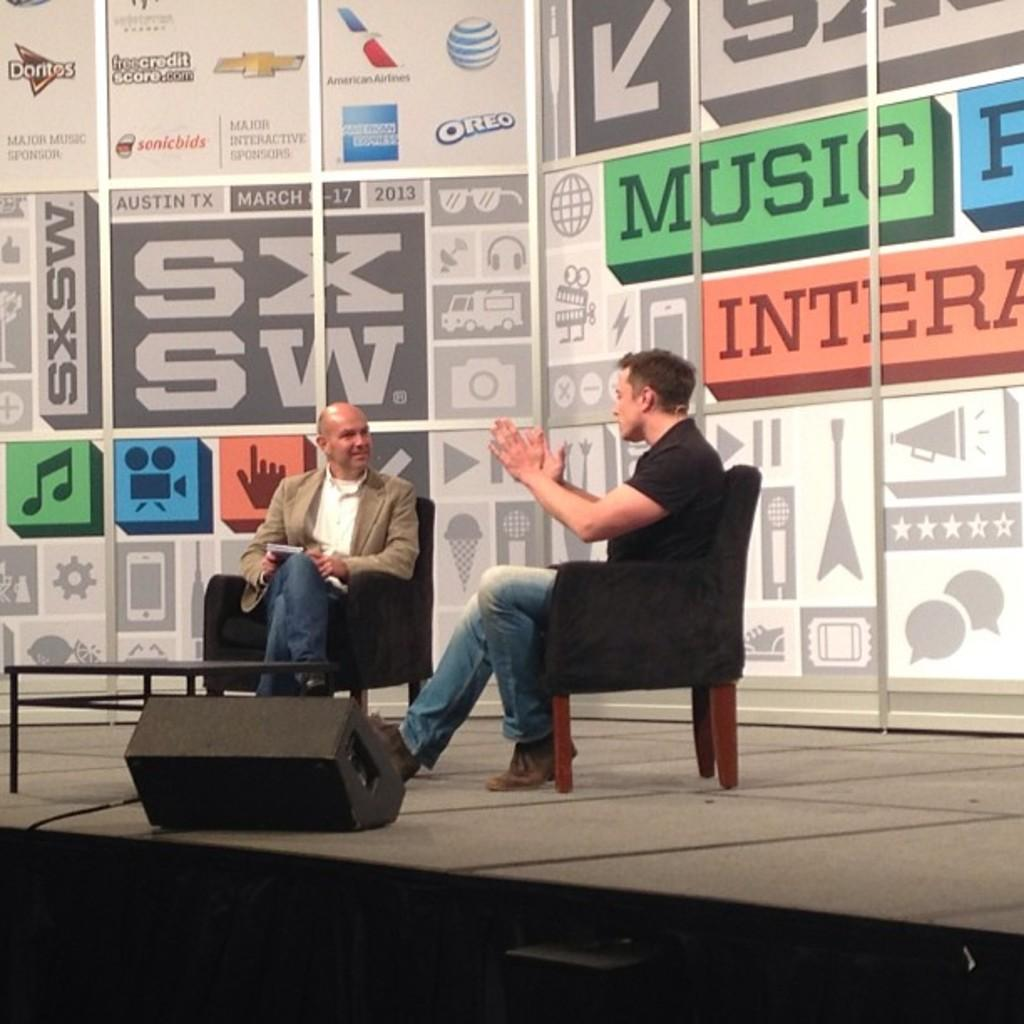How many people are on the stage in the image? There are two persons sitting on a chair on the stage. What are the two persons doing on the stage? The two persons are having a conversation. What can be seen in the background of the image? There is a hoarding in the background of the image. What is the reason for the low driving skills of the person in the image? There is no person driving in the image, and therefore no driving skills to assess. 